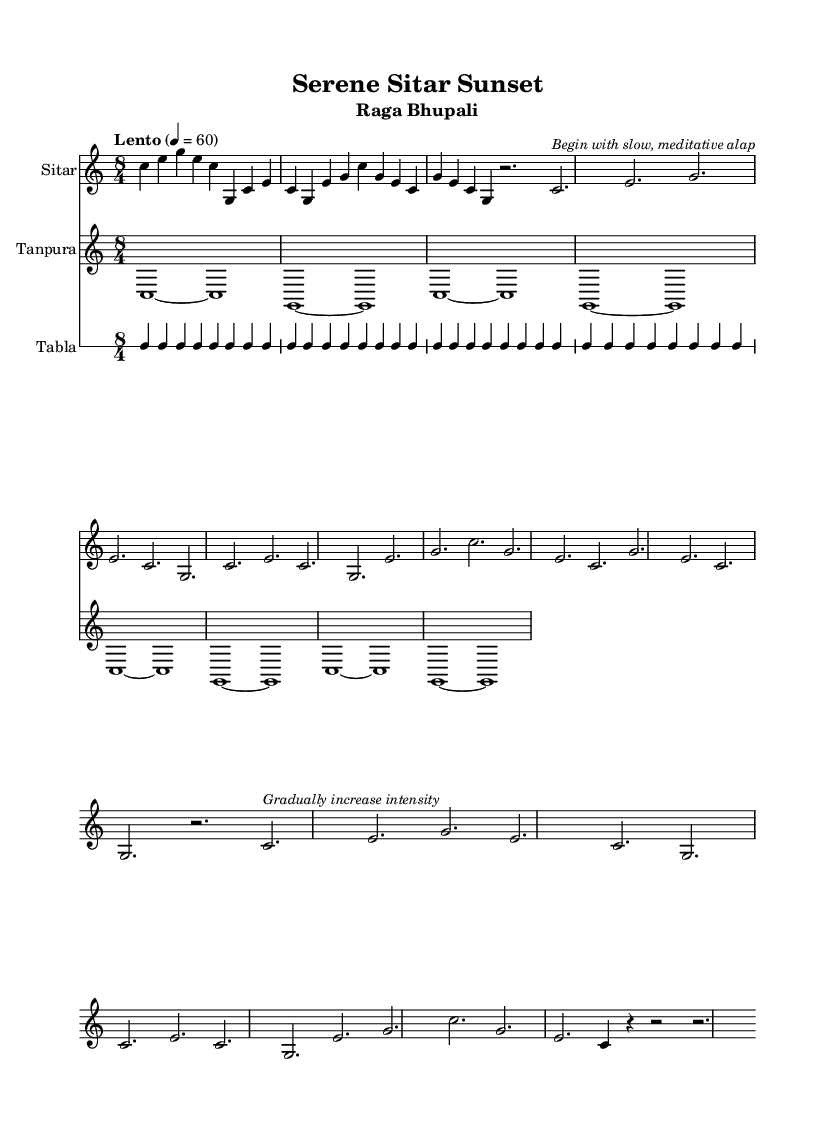What is the key signature of this music? The key signature is located at the beginning of the staff, represented by no sharps or flats, indicating C major.
Answer: C major What is the time signature of this music? The time signature is found at the start of the score, shown as "8/4", which indicates there are eight beats per measure and that the quarter note gets one beat.
Answer: 8/4 What is the tempo marking of this piece? The tempo marking appears at the top of the music, stated as "Lento" with a beat set to 60. Thus, it indicates to play slowly at a regular pace of 60 beats per minute.
Answer: Lento What is the primary instrument in this piece? The primary instrument is specified in the staff settings; the first staff clearly states "Sitar" as the instrument name.
Answer: Sitar How many measures are in the main phrase of the sitar part? Count the measures shown in the first segment of the sitar part; there are four measures that make up the main phrase before any repeats or variations are noted.
Answer: 4 What type of Raga is featured in this piece? The title at the top of the sheet music indicates that this piece is based on "Raga Bhupali." The specific naming represents its classification within Indian classical music.
Answer: Raga Bhupali What performance indication is given after the main phrase? Located under the global section, the marking instructs "Begin with slow, meditative alap," which is an indication of how to approach the performance originally after playing the main phrase.
Answer: Begin with slow, meditative alap 